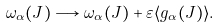Convert formula to latex. <formula><loc_0><loc_0><loc_500><loc_500>\omega _ { \alpha } ( { J } ) \longrightarrow \omega _ { \alpha } ( { J } ) + \varepsilon \langle g _ { \alpha } ( { J } ) \rangle .</formula> 